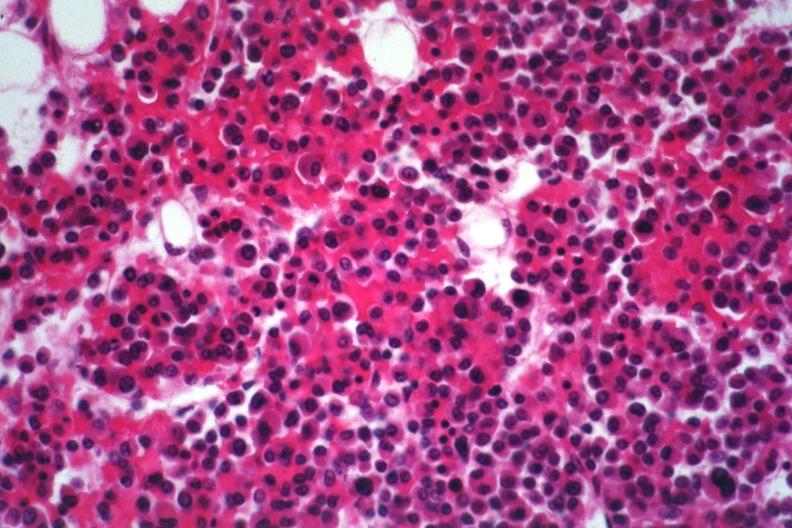what is present?
Answer the question using a single word or phrase. Hematologic 